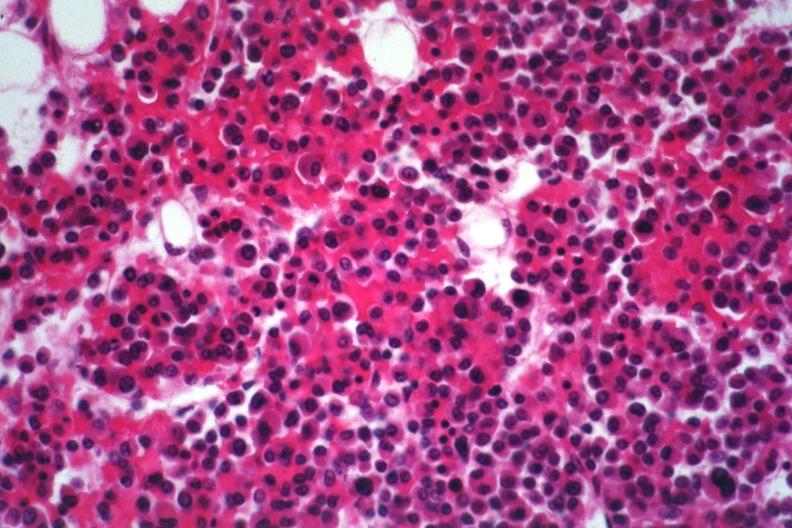what is present?
Answer the question using a single word or phrase. Hematologic 